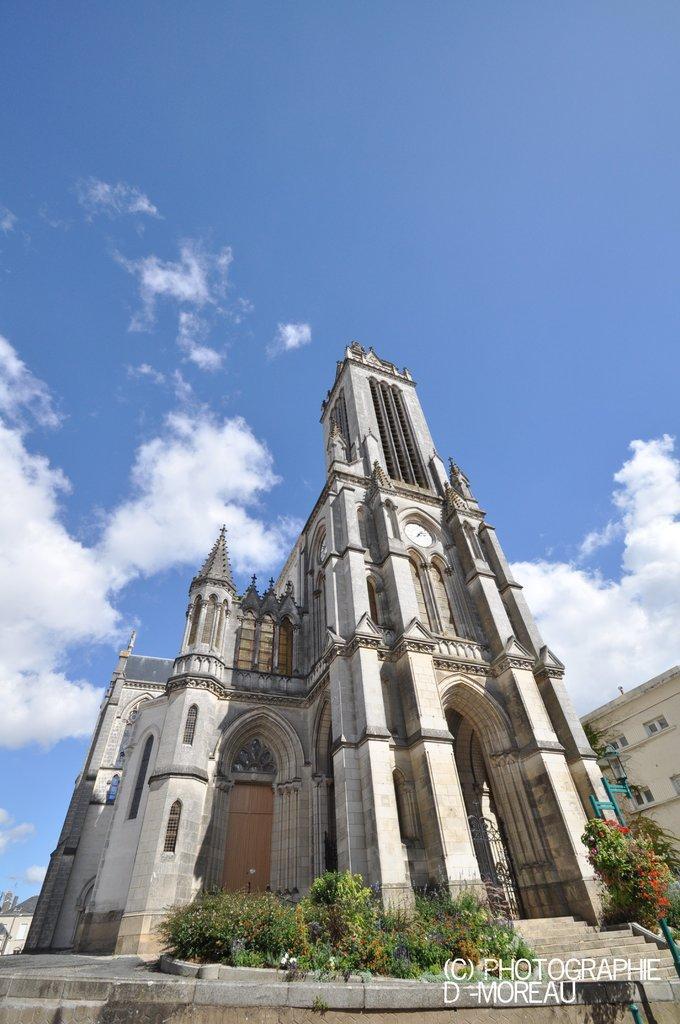In one or two sentences, can you explain what this image depicts? In the image we can see in front there is a clock tower building and there are small plants in between, behind there is another building and there are stairs. There is clear sky on the top. 